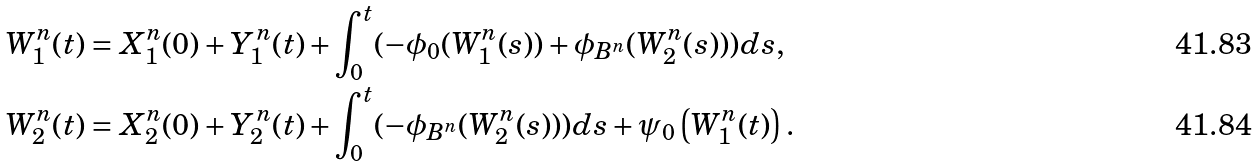<formula> <loc_0><loc_0><loc_500><loc_500>W _ { 1 } ^ { n } ( t ) & = X _ { 1 } ^ { n } ( 0 ) + Y ^ { n } _ { 1 } ( t ) + \int _ { 0 } ^ { t } ( - \phi _ { 0 } ( W _ { 1 } ^ { n } ( s ) ) + \phi _ { B ^ { n } } ( W _ { 2 } ^ { n } ( s ) ) ) d s , \\ W _ { 2 } ^ { n } ( t ) & = X _ { 2 } ^ { n } ( 0 ) + Y ^ { n } _ { 2 } ( t ) + \int _ { 0 } ^ { t } ( - \phi _ { B ^ { n } } ( W _ { 2 } ^ { n } ( s ) ) ) d s + \psi _ { 0 } \left ( W _ { 1 } ^ { n } ( t ) \right ) .</formula> 